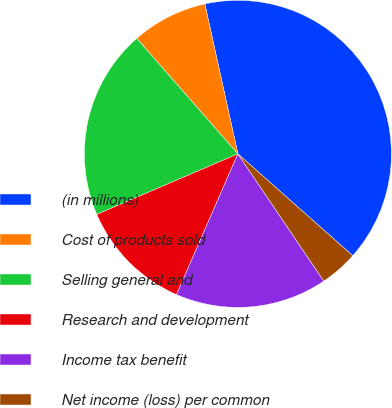<chart> <loc_0><loc_0><loc_500><loc_500><pie_chart><fcel>(in millions)<fcel>Cost of products sold<fcel>Selling general and<fcel>Research and development<fcel>Income tax benefit<fcel>Net income (loss) per common<nl><fcel>40.0%<fcel>8.0%<fcel>20.0%<fcel>12.0%<fcel>16.0%<fcel>4.0%<nl></chart> 